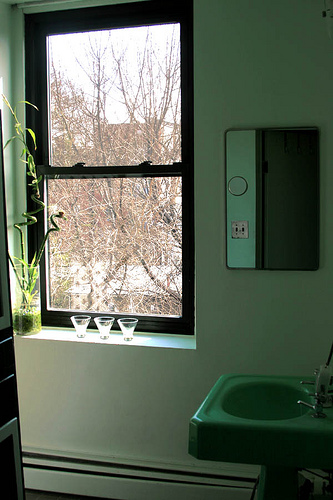<image>
Can you confirm if the glass is in front of the window? Yes. The glass is positioned in front of the window, appearing closer to the camera viewpoint. 